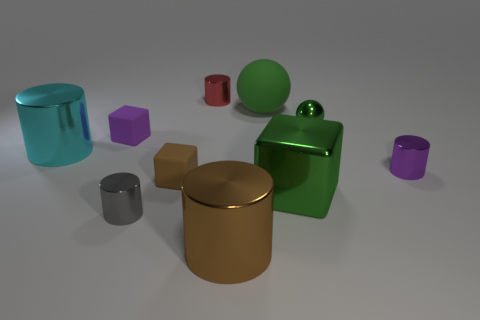Subtract all cyan cylinders. How many cylinders are left? 4 Subtract all tiny red metal cylinders. How many cylinders are left? 4 Subtract all blue cylinders. Subtract all gray balls. How many cylinders are left? 5 Subtract all cubes. How many objects are left? 7 Subtract all large green blocks. Subtract all large green cubes. How many objects are left? 8 Add 2 small brown matte things. How many small brown matte things are left? 3 Add 3 small gray things. How many small gray things exist? 4 Subtract 1 green cubes. How many objects are left? 9 